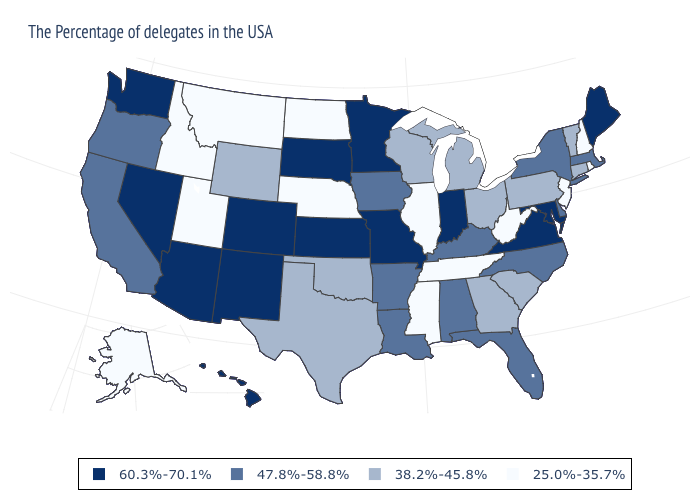What is the value of Connecticut?
Concise answer only. 38.2%-45.8%. Which states have the highest value in the USA?
Quick response, please. Maine, Maryland, Virginia, Indiana, Missouri, Minnesota, Kansas, South Dakota, Colorado, New Mexico, Arizona, Nevada, Washington, Hawaii. What is the value of South Carolina?
Quick response, please. 38.2%-45.8%. Among the states that border Florida , which have the highest value?
Quick response, please. Alabama. What is the lowest value in states that border Washington?
Give a very brief answer. 25.0%-35.7%. Name the states that have a value in the range 47.8%-58.8%?
Short answer required. Massachusetts, New York, Delaware, North Carolina, Florida, Kentucky, Alabama, Louisiana, Arkansas, Iowa, California, Oregon. Among the states that border Michigan , does Indiana have the highest value?
Concise answer only. Yes. Name the states that have a value in the range 47.8%-58.8%?
Answer briefly. Massachusetts, New York, Delaware, North Carolina, Florida, Kentucky, Alabama, Louisiana, Arkansas, Iowa, California, Oregon. Name the states that have a value in the range 38.2%-45.8%?
Be succinct. Vermont, Connecticut, Pennsylvania, South Carolina, Ohio, Georgia, Michigan, Wisconsin, Oklahoma, Texas, Wyoming. Among the states that border Wisconsin , which have the lowest value?
Be succinct. Illinois. Name the states that have a value in the range 60.3%-70.1%?
Short answer required. Maine, Maryland, Virginia, Indiana, Missouri, Minnesota, Kansas, South Dakota, Colorado, New Mexico, Arizona, Nevada, Washington, Hawaii. Which states have the highest value in the USA?
Be succinct. Maine, Maryland, Virginia, Indiana, Missouri, Minnesota, Kansas, South Dakota, Colorado, New Mexico, Arizona, Nevada, Washington, Hawaii. Among the states that border North Dakota , does Montana have the lowest value?
Quick response, please. Yes. What is the value of New Mexico?
Give a very brief answer. 60.3%-70.1%. Among the states that border Kansas , which have the highest value?
Answer briefly. Missouri, Colorado. 